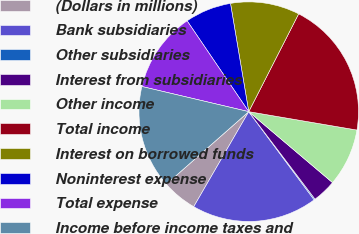<chart> <loc_0><loc_0><loc_500><loc_500><pie_chart><fcel>(Dollars in millions)<fcel>Bank subsidiaries<fcel>Other subsidiaries<fcel>Interest from subsidiaries<fcel>Other income<fcel>Total income<fcel>Interest on borrowed funds<fcel>Noninterest expense<fcel>Total expense<fcel>Income before income taxes and<nl><fcel>5.16%<fcel>18.51%<fcel>0.16%<fcel>3.5%<fcel>8.5%<fcel>20.17%<fcel>10.17%<fcel>6.83%<fcel>11.83%<fcel>15.17%<nl></chart> 